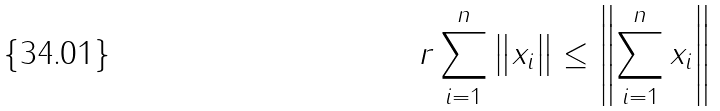Convert formula to latex. <formula><loc_0><loc_0><loc_500><loc_500>r \sum _ { i = 1 } ^ { n } \left \| x _ { i } \right \| \leq \left \| \sum _ { i = 1 } ^ { n } x _ { i } \right \|</formula> 